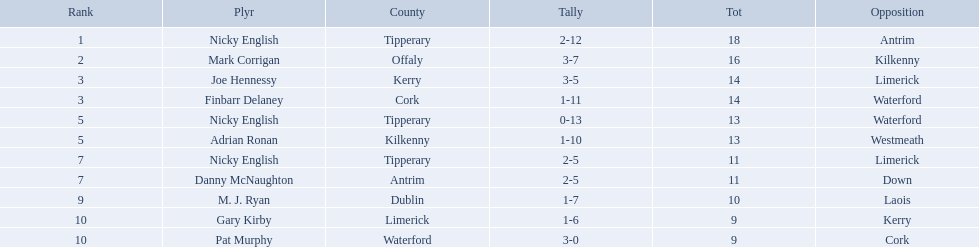Who are all the players? Nicky English, Mark Corrigan, Joe Hennessy, Finbarr Delaney, Nicky English, Adrian Ronan, Nicky English, Danny McNaughton, M. J. Ryan, Gary Kirby, Pat Murphy. How many points did they receive? 18, 16, 14, 14, 13, 13, 11, 11, 10, 9, 9. And which player received 10 points? M. J. Ryan. 